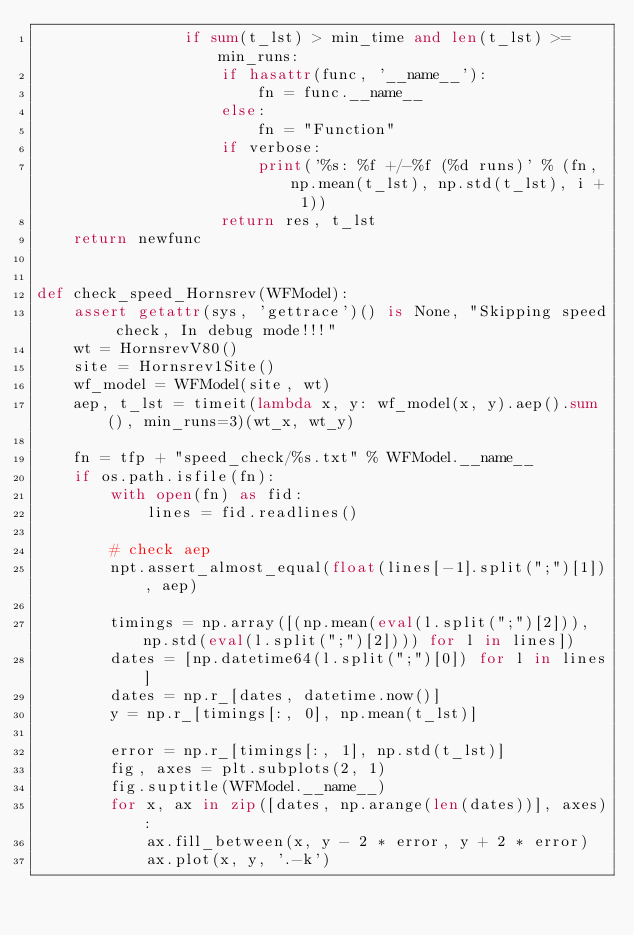<code> <loc_0><loc_0><loc_500><loc_500><_Python_>                if sum(t_lst) > min_time and len(t_lst) >= min_runs:
                    if hasattr(func, '__name__'):
                        fn = func.__name__
                    else:
                        fn = "Function"
                    if verbose:
                        print('%s: %f +/-%f (%d runs)' % (fn, np.mean(t_lst), np.std(t_lst), i + 1))
                    return res, t_lst
    return newfunc


def check_speed_Hornsrev(WFModel):
    assert getattr(sys, 'gettrace')() is None, "Skipping speed check, In debug mode!!!"
    wt = HornsrevV80()
    site = Hornsrev1Site()
    wf_model = WFModel(site, wt)
    aep, t_lst = timeit(lambda x, y: wf_model(x, y).aep().sum(), min_runs=3)(wt_x, wt_y)

    fn = tfp + "speed_check/%s.txt" % WFModel.__name__
    if os.path.isfile(fn):
        with open(fn) as fid:
            lines = fid.readlines()

        # check aep
        npt.assert_almost_equal(float(lines[-1].split(";")[1]), aep)

        timings = np.array([(np.mean(eval(l.split(";")[2])), np.std(eval(l.split(";")[2]))) for l in lines])
        dates = [np.datetime64(l.split(";")[0]) for l in lines]
        dates = np.r_[dates, datetime.now()]
        y = np.r_[timings[:, 0], np.mean(t_lst)]

        error = np.r_[timings[:, 1], np.std(t_lst)]
        fig, axes = plt.subplots(2, 1)
        fig.suptitle(WFModel.__name__)
        for x, ax in zip([dates, np.arange(len(dates))], axes):
            ax.fill_between(x, y - 2 * error, y + 2 * error)
            ax.plot(x, y, '.-k')</code> 